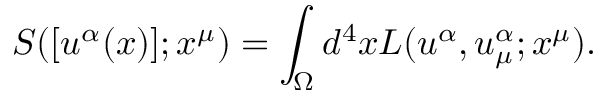Convert formula to latex. <formula><loc_0><loc_0><loc_500><loc_500>{ S } ( [ u ^ { \alpha } ( x ) ] ; x ^ { \mu } ) = \int _ { \Omega } d ^ { 4 } x { L } ( u ^ { \alpha } , u _ { \mu } ^ { \alpha } ; x ^ { \mu } ) .</formula> 